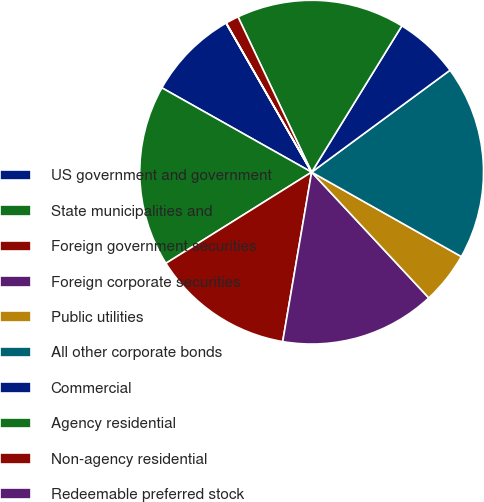<chart> <loc_0><loc_0><loc_500><loc_500><pie_chart><fcel>US government and government<fcel>State municipalities and<fcel>Foreign government securities<fcel>Foreign corporate securities<fcel>Public utilities<fcel>All other corporate bonds<fcel>Commercial<fcel>Agency residential<fcel>Non-agency residential<fcel>Redeemable preferred stock<nl><fcel>8.54%<fcel>17.06%<fcel>13.41%<fcel>14.63%<fcel>4.89%<fcel>18.28%<fcel>6.1%<fcel>15.84%<fcel>1.23%<fcel>0.02%<nl></chart> 